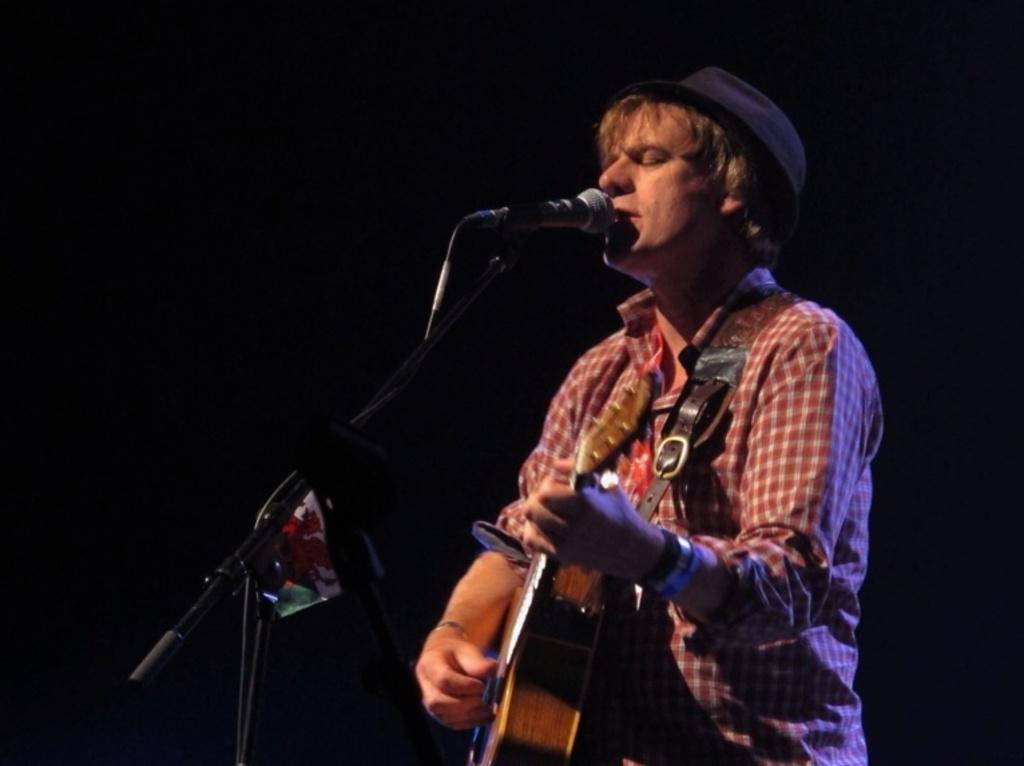Can you describe this image briefly? In the middle there is a man he wear check shirt and hat , he is playing guitar and singing. On the left there is a mic stand and mic. 